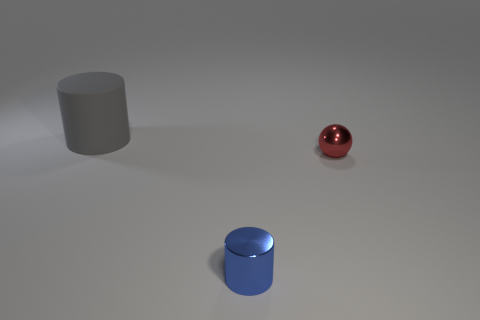Subtract all balls. How many objects are left? 2 Add 3 red things. How many objects exist? 6 Subtract all green cubes. How many brown spheres are left? 0 Subtract all yellow balls. Subtract all cyan cylinders. How many balls are left? 1 Subtract all small blue cylinders. Subtract all red metal spheres. How many objects are left? 1 Add 3 large gray cylinders. How many large gray cylinders are left? 4 Add 2 big gray shiny cylinders. How many big gray shiny cylinders exist? 2 Subtract 1 gray cylinders. How many objects are left? 2 